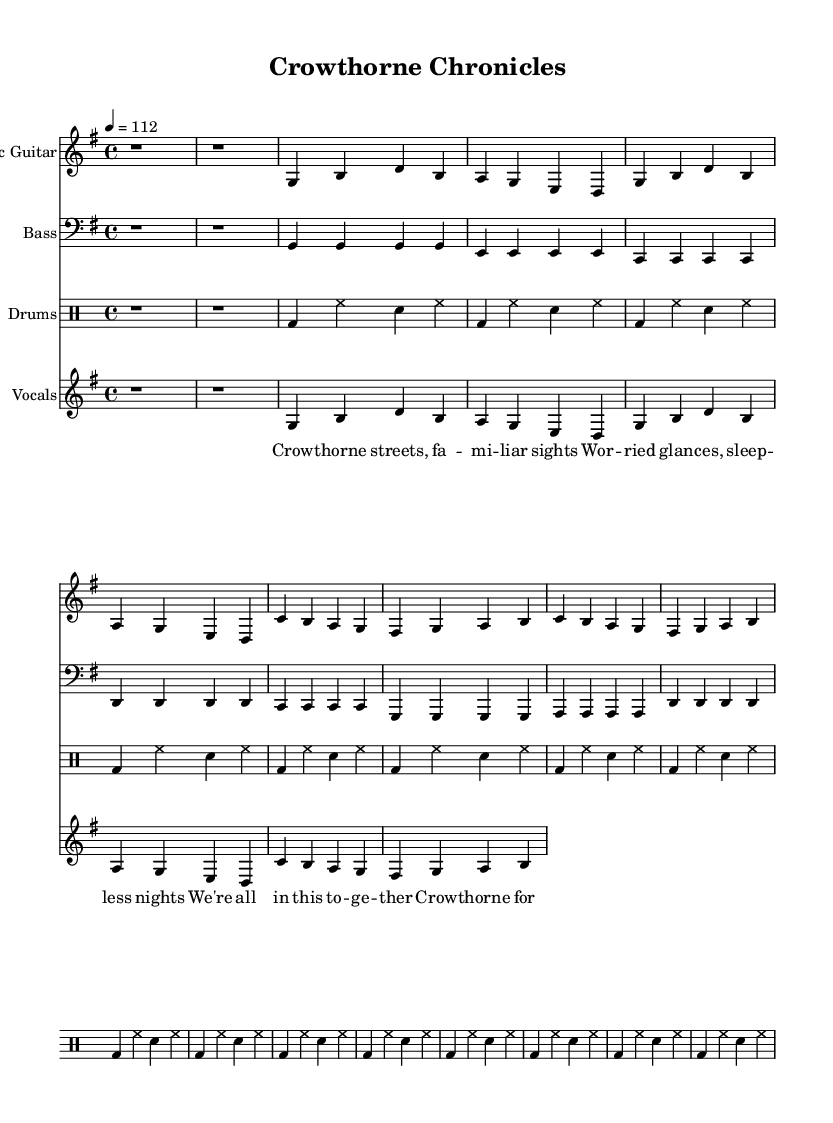What is the key signature of this music? The key signature is G major, which is indicated by one sharp (F#) in the key signature at the beginning of the staff.
Answer: G major What is the time signature of this music? The time signature is indicated at the beginning of the score as 4/4, meaning there are four beats in each measure and the quarter note gets one beat.
Answer: 4/4 What is the tempo marking for this piece? The tempo marking is given at the beginning of the score as 4 = 112, meaning there should be 112 beats per minute for the quarter note.
Answer: 112 How many measures are in the chorus section? The chorus section consists of two measures as specified by the bar lines and the lyrics indicate a break before returning to the verse.
Answer: 2 What is the primary theme reflected in the lyrics? The lyrics convey feelings of connection and community in Crowthorne, suggesting a sense of belonging and shared experiences in small-town life.
Answer: Community How many distinct instruments are used in the arrangement? The arrangement includes three distinct instruments: electric guitar, bass guitar, and drums, along with vocal parts.
Answer: 3 What type of musical form is primarily used in this piece? The piece follows a verse-chorus structure, alternating between verses and the chorus, which is common in rock music to enhance memorability and emotional emphasis.
Answer: Verse-chorus 